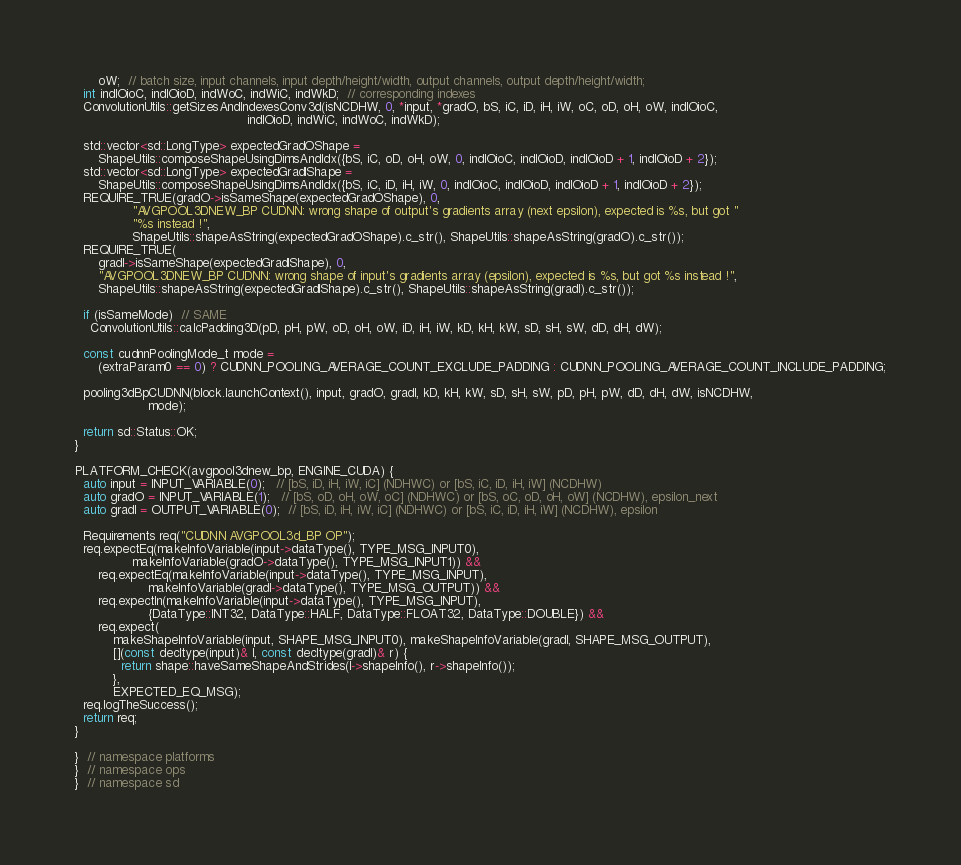<code> <loc_0><loc_0><loc_500><loc_500><_Cuda_>      oW;  // batch size, input channels, input depth/height/width, output channels, output depth/height/width;
  int indIOioC, indIOioD, indWoC, indWiC, indWkD;  // corresponding indexes
  ConvolutionUtils::getSizesAndIndexesConv3d(isNCDHW, 0, *input, *gradO, bS, iC, iD, iH, iW, oC, oD, oH, oW, indIOioC,
                                             indIOioD, indWiC, indWoC, indWkD);

  std::vector<sd::LongType> expectedGradOShape =
      ShapeUtils::composeShapeUsingDimsAndIdx({bS, iC, oD, oH, oW, 0, indIOioC, indIOioD, indIOioD + 1, indIOioD + 2});
  std::vector<sd::LongType> expectedGradIShape =
      ShapeUtils::composeShapeUsingDimsAndIdx({bS, iC, iD, iH, iW, 0, indIOioC, indIOioD, indIOioD + 1, indIOioD + 2});
  REQUIRE_TRUE(gradO->isSameShape(expectedGradOShape), 0,
               "AVGPOOL3DNEW_BP CUDNN: wrong shape of output's gradients array (next epsilon), expected is %s, but got "
               "%s instead !",
               ShapeUtils::shapeAsString(expectedGradOShape).c_str(), ShapeUtils::shapeAsString(gradO).c_str());
  REQUIRE_TRUE(
      gradI->isSameShape(expectedGradIShape), 0,
      "AVGPOOL3DNEW_BP CUDNN: wrong shape of input's gradients array (epsilon), expected is %s, but got %s instead !",
      ShapeUtils::shapeAsString(expectedGradIShape).c_str(), ShapeUtils::shapeAsString(gradI).c_str());

  if (isSameMode)  // SAME
    ConvolutionUtils::calcPadding3D(pD, pH, pW, oD, oH, oW, iD, iH, iW, kD, kH, kW, sD, sH, sW, dD, dH, dW);

  const cudnnPoolingMode_t mode =
      (extraParam0 == 0) ? CUDNN_POOLING_AVERAGE_COUNT_EXCLUDE_PADDING : CUDNN_POOLING_AVERAGE_COUNT_INCLUDE_PADDING;

  pooling3dBpCUDNN(block.launchContext(), input, gradO, gradI, kD, kH, kW, sD, sH, sW, pD, pH, pW, dD, dH, dW, isNCDHW,
                   mode);

  return sd::Status::OK;
}

PLATFORM_CHECK(avgpool3dnew_bp, ENGINE_CUDA) {
  auto input = INPUT_VARIABLE(0);   // [bS, iD, iH, iW, iC] (NDHWC) or [bS, iC, iD, iH, iW] (NCDHW)
  auto gradO = INPUT_VARIABLE(1);   // [bS, oD, oH, oW, oC] (NDHWC) or [bS, oC, oD, oH, oW] (NCDHW), epsilon_next
  auto gradI = OUTPUT_VARIABLE(0);  // [bS, iD, iH, iW, iC] (NDHWC) or [bS, iC, iD, iH, iW] (NCDHW), epsilon

  Requirements req("CUDNN AVGPOOL3d_BP OP");
  req.expectEq(makeInfoVariable(input->dataType(), TYPE_MSG_INPUT0),
               makeInfoVariable(gradO->dataType(), TYPE_MSG_INPUT1)) &&
      req.expectEq(makeInfoVariable(input->dataType(), TYPE_MSG_INPUT),
                   makeInfoVariable(gradI->dataType(), TYPE_MSG_OUTPUT)) &&
      req.expectIn(makeInfoVariable(input->dataType(), TYPE_MSG_INPUT),
                   {DataType::INT32, DataType::HALF, DataType::FLOAT32, DataType::DOUBLE}) &&
      req.expect(
          makeShapeInfoVariable(input, SHAPE_MSG_INPUT0), makeShapeInfoVariable(gradI, SHAPE_MSG_OUTPUT),
          [](const decltype(input)& l, const decltype(gradI)& r) {
            return shape::haveSameShapeAndStrides(l->shapeInfo(), r->shapeInfo());
          },
          EXPECTED_EQ_MSG);
  req.logTheSuccess();
  return req;
}

}  // namespace platforms
}  // namespace ops
}  // namespace sd
</code> 